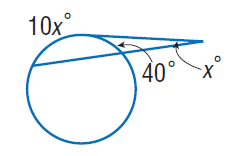Answer the mathemtical geometry problem and directly provide the correct option letter.
Question: Find x. Assume that any segment that appears to be tangent is tangent.
Choices: A: 5 B: 40 C: 50 D: 90 A 